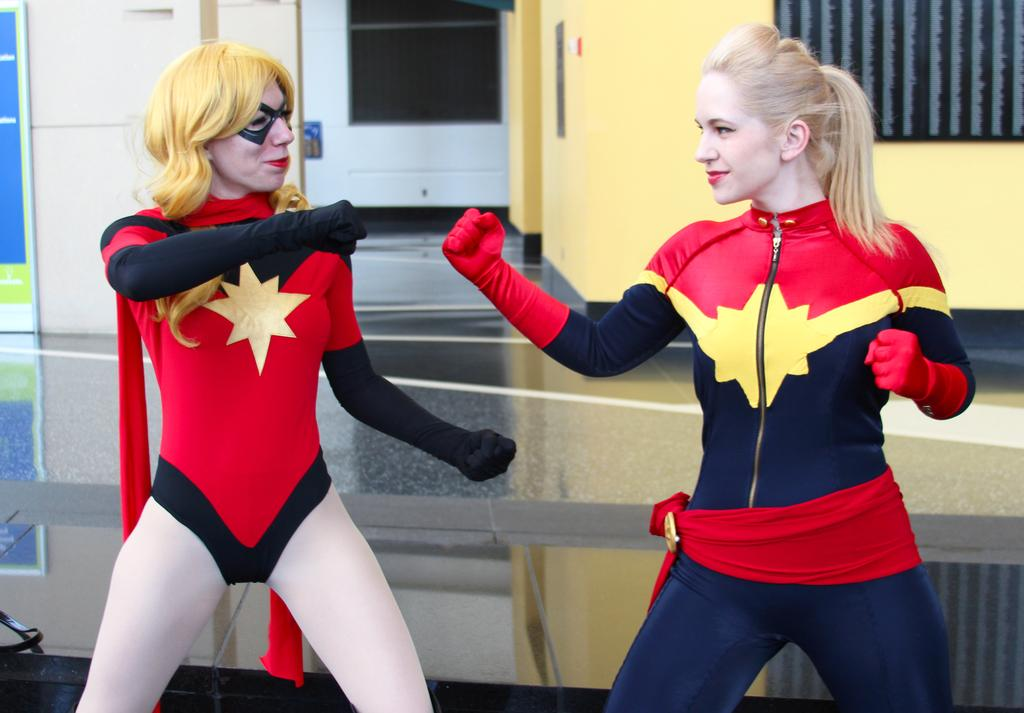How many people are in the image? There are two people standing in the center of the image. What are the people wearing? The people are wearing costumes. What can be seen on the wall in the background? There is a board placed on the wall in the background. What architectural feature is visible in the background? There is a door in the background. What type of harmony is being played by the people in the image? There is no indication of music or harmony in the image; the people are simply standing and wearing costumes. 